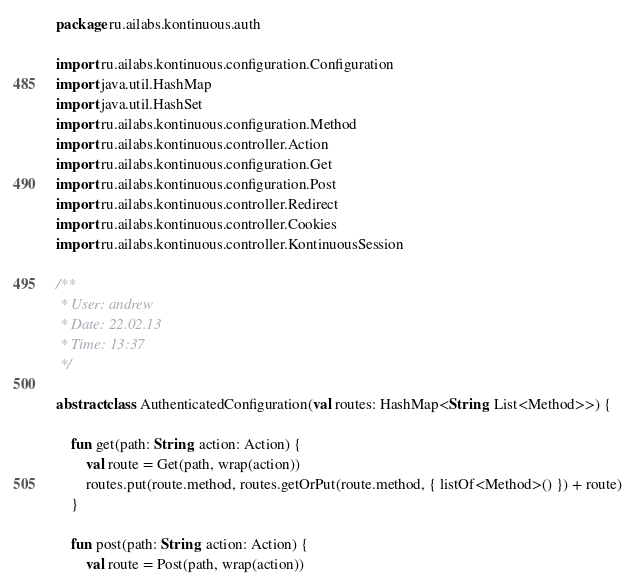Convert code to text. <code><loc_0><loc_0><loc_500><loc_500><_Kotlin_>package ru.ailabs.kontinuous.auth

import ru.ailabs.kontinuous.configuration.Configuration
import java.util.HashMap
import java.util.HashSet
import ru.ailabs.kontinuous.configuration.Method
import ru.ailabs.kontinuous.controller.Action
import ru.ailabs.kontinuous.configuration.Get
import ru.ailabs.kontinuous.configuration.Post
import ru.ailabs.kontinuous.controller.Redirect
import ru.ailabs.kontinuous.controller.Cookies
import ru.ailabs.kontinuous.controller.KontinuousSession

/**
 * User: andrew
 * Date: 22.02.13
 * Time: 13:37
 */

abstract class AuthenticatedConfiguration(val routes: HashMap<String, List<Method>>) {

    fun get(path: String, action: Action) {
        val route = Get(path, wrap(action))
        routes.put(route.method, routes.getOrPut(route.method, { listOf<Method>() }) + route)
    }

    fun post(path: String, action: Action) {
        val route = Post(path, wrap(action))</code> 